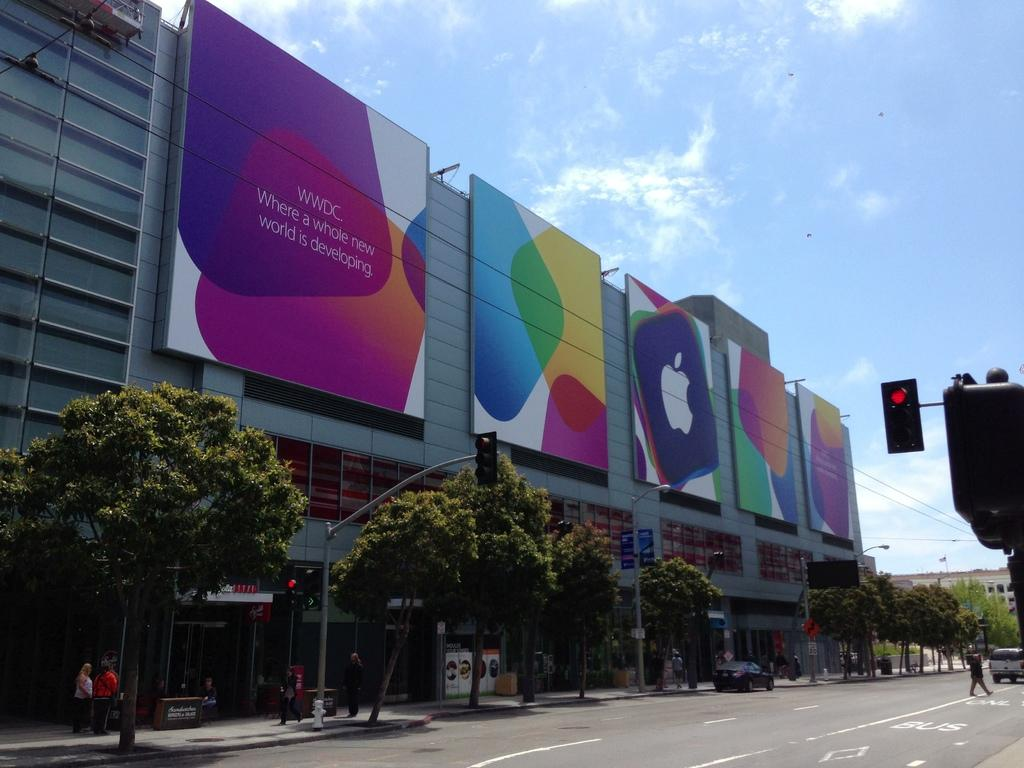<image>
Describe the image concisely. The WWDC is advertised on a multi-piece billboard. 